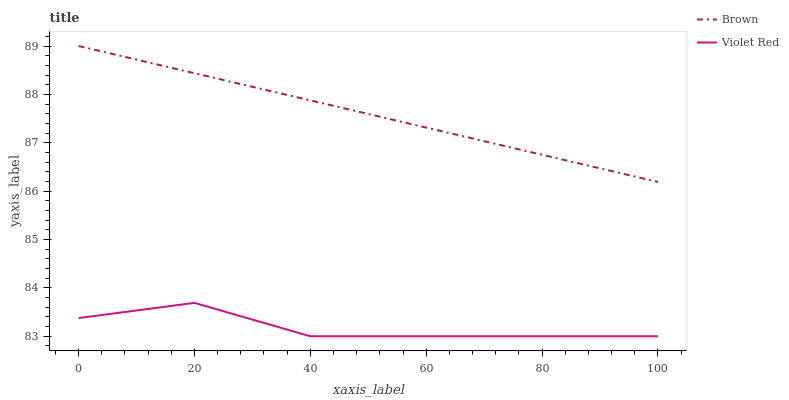Does Violet Red have the minimum area under the curve?
Answer yes or no. Yes. Does Brown have the maximum area under the curve?
Answer yes or no. Yes. Does Violet Red have the maximum area under the curve?
Answer yes or no. No. Is Brown the smoothest?
Answer yes or no. Yes. Is Violet Red the roughest?
Answer yes or no. Yes. Is Violet Red the smoothest?
Answer yes or no. No. Does Violet Red have the lowest value?
Answer yes or no. Yes. Does Brown have the highest value?
Answer yes or no. Yes. Does Violet Red have the highest value?
Answer yes or no. No. Is Violet Red less than Brown?
Answer yes or no. Yes. Is Brown greater than Violet Red?
Answer yes or no. Yes. Does Violet Red intersect Brown?
Answer yes or no. No. 